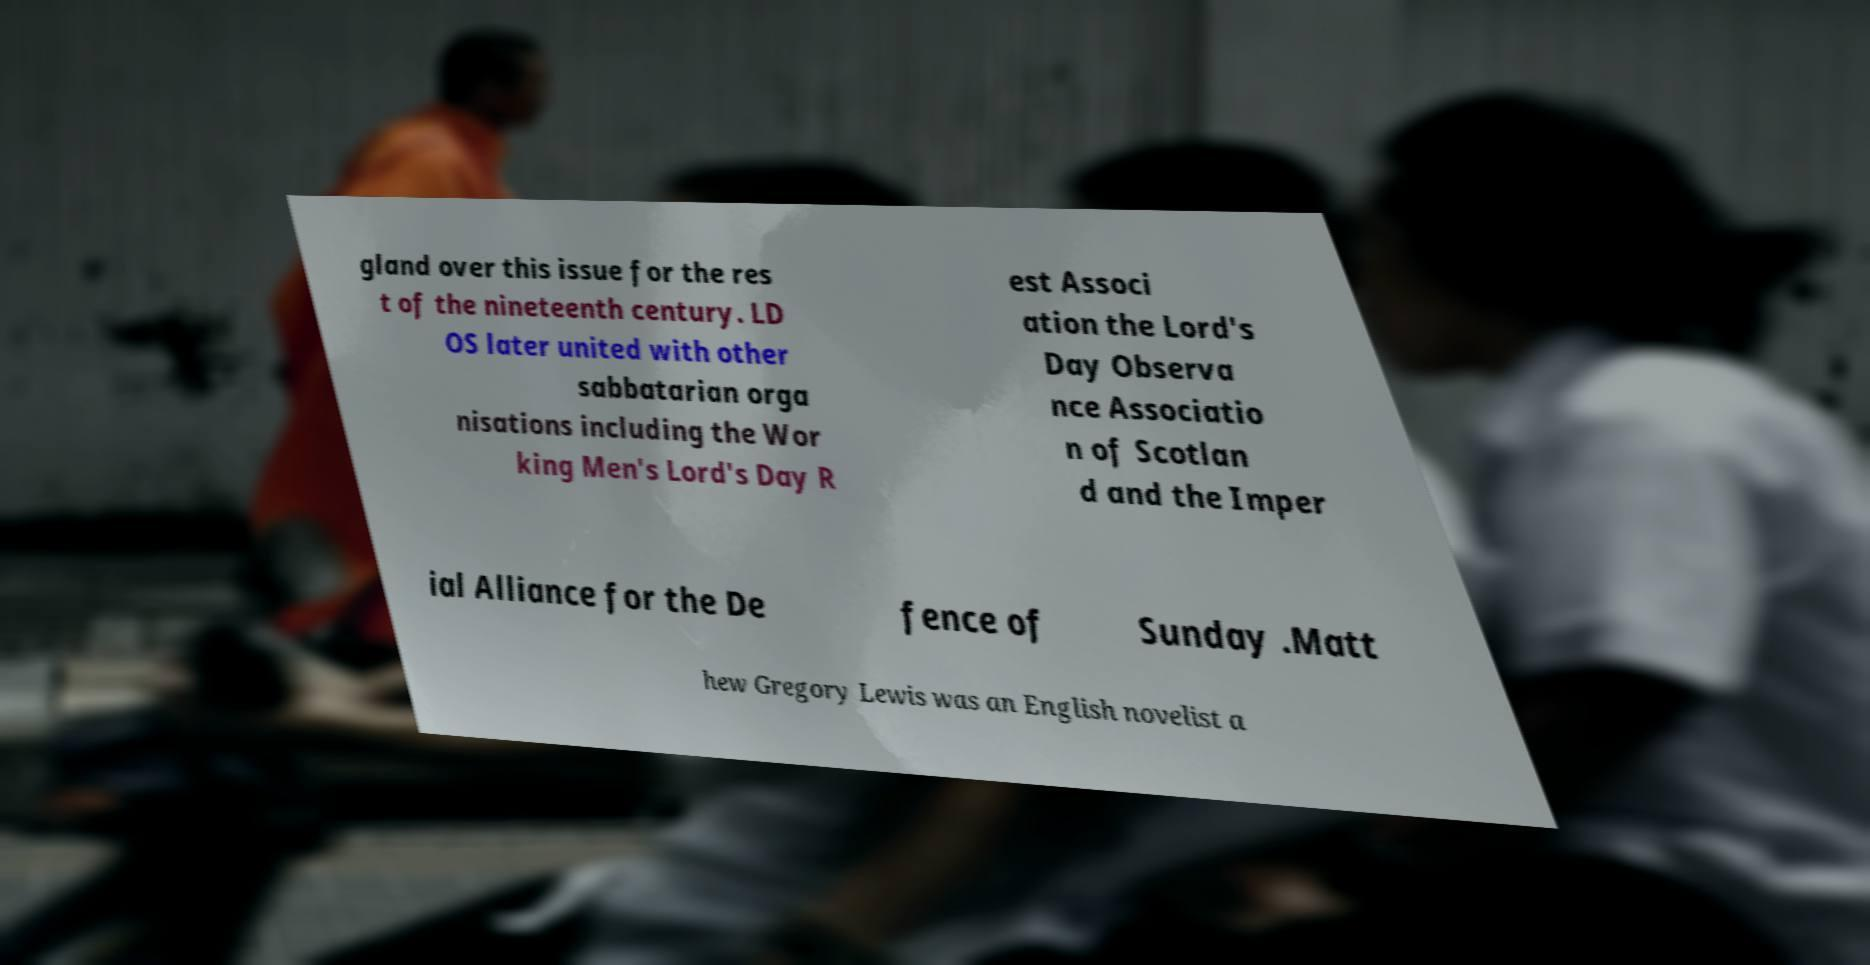Can you read and provide the text displayed in the image?This photo seems to have some interesting text. Can you extract and type it out for me? gland over this issue for the res t of the nineteenth century. LD OS later united with other sabbatarian orga nisations including the Wor king Men's Lord's Day R est Associ ation the Lord's Day Observa nce Associatio n of Scotlan d and the Imper ial Alliance for the De fence of Sunday .Matt hew Gregory Lewis was an English novelist a 